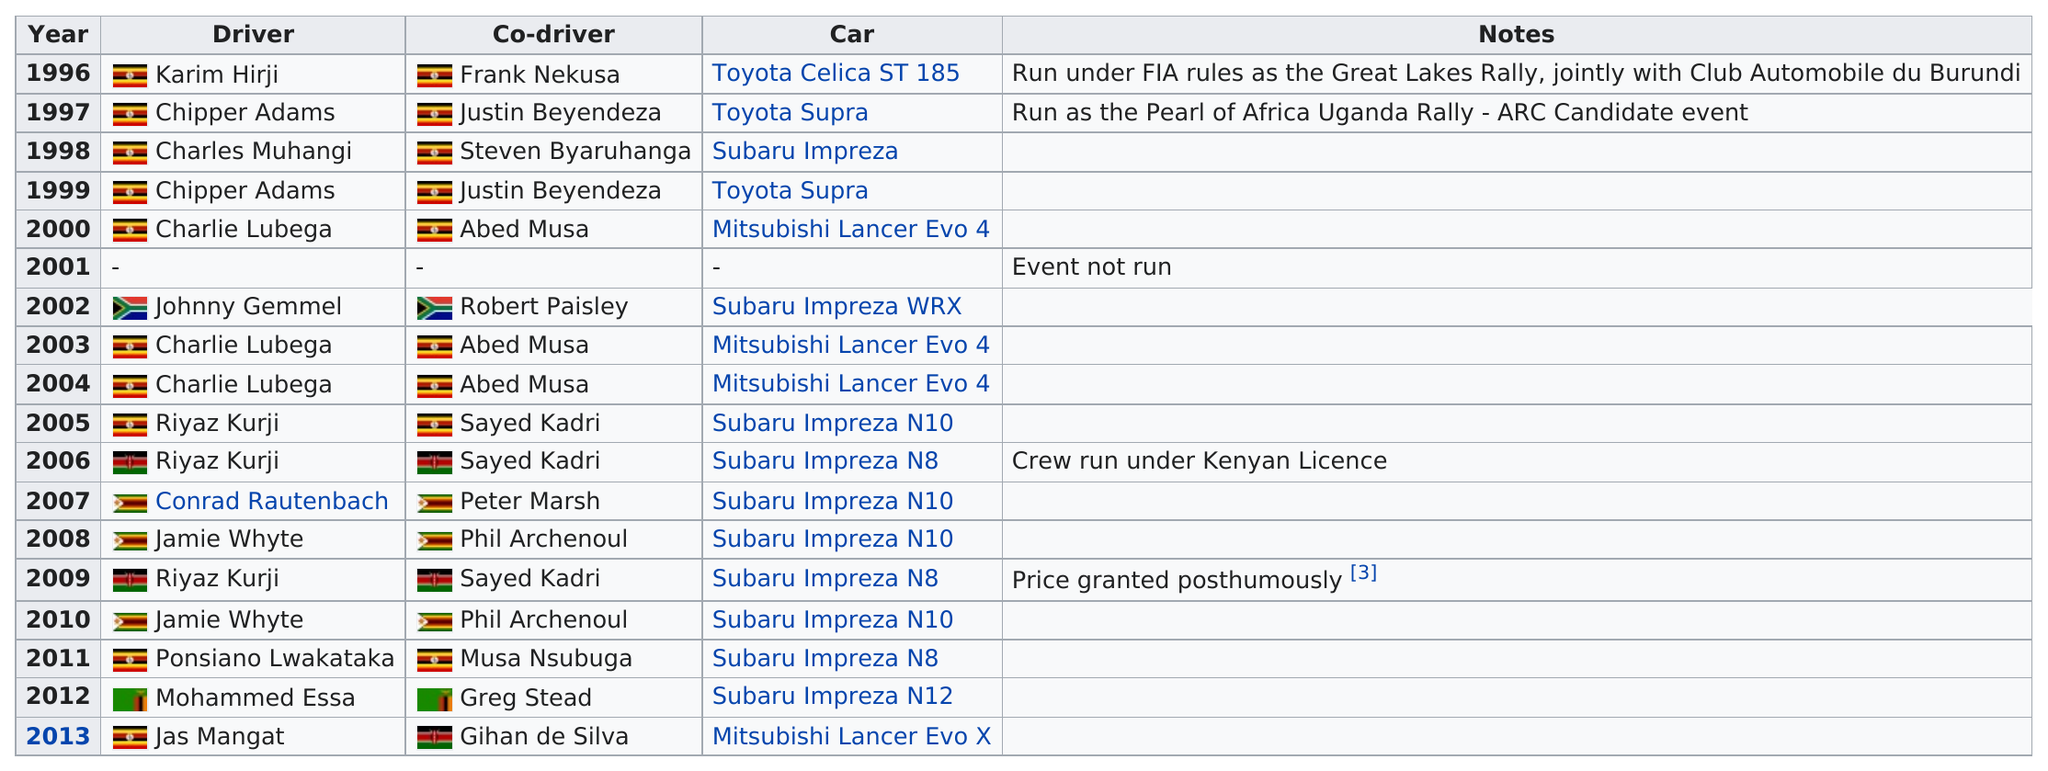Point out several critical features in this image. Four drivers have won at least twice. The winning driver of the Toyota Supra was driving it 2 times. Chipper Adams and Justin Bieber have won two. The Mitsubishi Lancer was the winning car a total of two times before the year 2004. There is currently one driver competing alongside a co-driver from a different country in the event. 